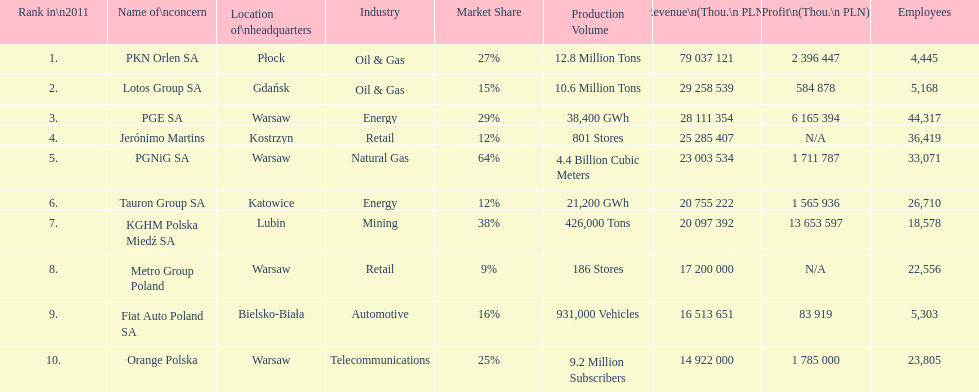How many companies had over $1,000,000 profit? 6. 